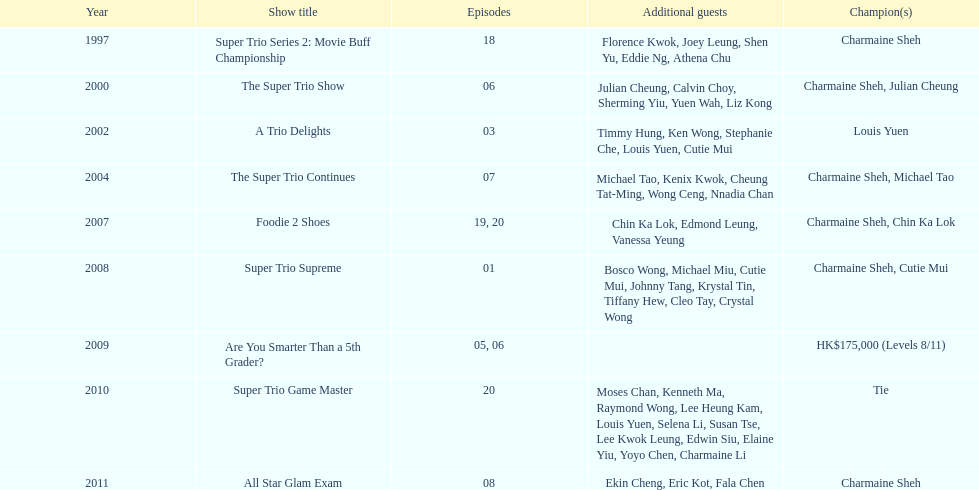What year was the only year were a tie occurred? 2010. Could you help me parse every detail presented in this table? {'header': ['Year', 'Show title', 'Episodes', 'Additional guests', 'Champion(s)'], 'rows': [['1997', 'Super Trio Series 2: Movie Buff Championship', '18', 'Florence Kwok, Joey Leung, Shen Yu, Eddie Ng, Athena Chu', 'Charmaine Sheh'], ['2000', 'The Super Trio Show', '06', 'Julian Cheung, Calvin Choy, Sherming Yiu, Yuen Wah, Liz Kong', 'Charmaine Sheh, Julian Cheung'], ['2002', 'A Trio Delights', '03', 'Timmy Hung, Ken Wong, Stephanie Che, Louis Yuen, Cutie Mui', 'Louis Yuen'], ['2004', 'The Super Trio Continues', '07', 'Michael Tao, Kenix Kwok, Cheung Tat-Ming, Wong Ceng, Nnadia Chan', 'Charmaine Sheh, Michael Tao'], ['2007', 'Foodie 2 Shoes', '19, 20', 'Chin Ka Lok, Edmond Leung, Vanessa Yeung', 'Charmaine Sheh, Chin Ka Lok'], ['2008', 'Super Trio Supreme', '01', 'Bosco Wong, Michael Miu, Cutie Mui, Johnny Tang, Krystal Tin, Tiffany Hew, Cleo Tay, Crystal Wong', 'Charmaine Sheh, Cutie Mui'], ['2009', 'Are You Smarter Than a 5th Grader?', '05, 06', '', 'HK$175,000 (Levels 8/11)'], ['2010', 'Super Trio Game Master', '20', 'Moses Chan, Kenneth Ma, Raymond Wong, Lee Heung Kam, Louis Yuen, Selena Li, Susan Tse, Lee Kwok Leung, Edwin Siu, Elaine Yiu, Yoyo Chen, Charmaine Li', 'Tie'], ['2011', 'All Star Glam Exam', '08', 'Ekin Cheng, Eric Kot, Fala Chen', 'Charmaine Sheh']]} 